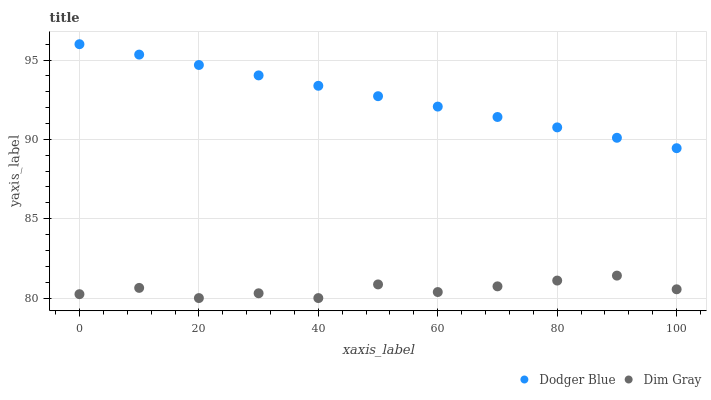Does Dim Gray have the minimum area under the curve?
Answer yes or no. Yes. Does Dodger Blue have the maximum area under the curve?
Answer yes or no. Yes. Does Dodger Blue have the minimum area under the curve?
Answer yes or no. No. Is Dodger Blue the smoothest?
Answer yes or no. Yes. Is Dim Gray the roughest?
Answer yes or no. Yes. Is Dodger Blue the roughest?
Answer yes or no. No. Does Dim Gray have the lowest value?
Answer yes or no. Yes. Does Dodger Blue have the lowest value?
Answer yes or no. No. Does Dodger Blue have the highest value?
Answer yes or no. Yes. Is Dim Gray less than Dodger Blue?
Answer yes or no. Yes. Is Dodger Blue greater than Dim Gray?
Answer yes or no. Yes. Does Dim Gray intersect Dodger Blue?
Answer yes or no. No. 